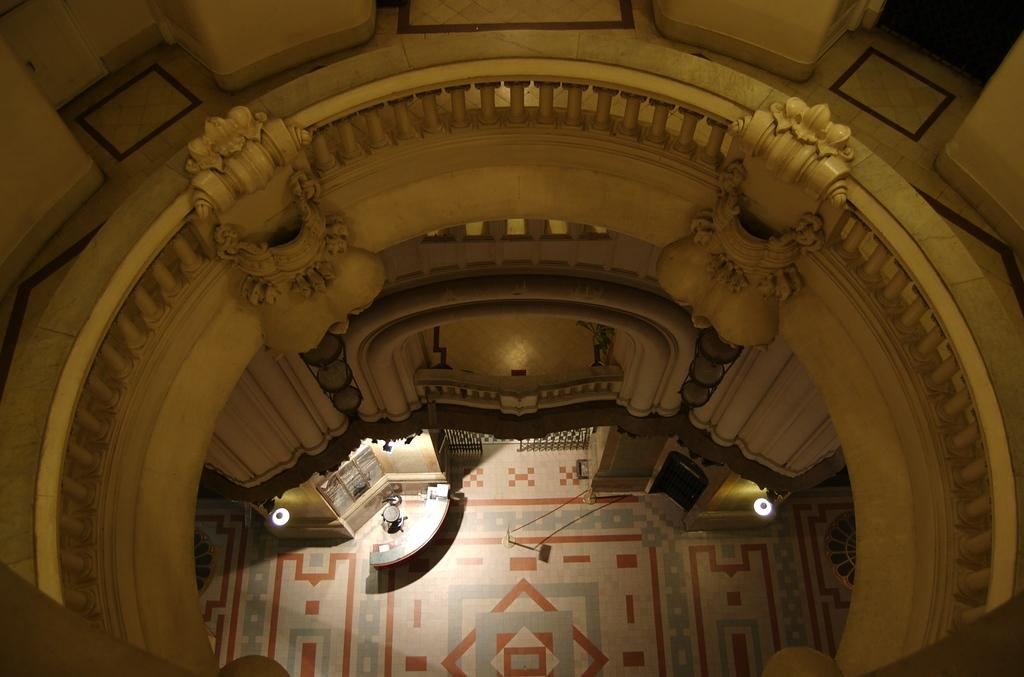Where was the image taken? The image was taken inside a building. What can be seen illuminated in the image? There are lights visible in the image. What surface is visible in the image? There is a floor visible in the image. What type of structure can be seen in the image? There is architecture visible in the image. What is one of the walls made of in the image? There is a wall visible in the image. Can you see a lake in the image? No, there is no lake present in the image. 